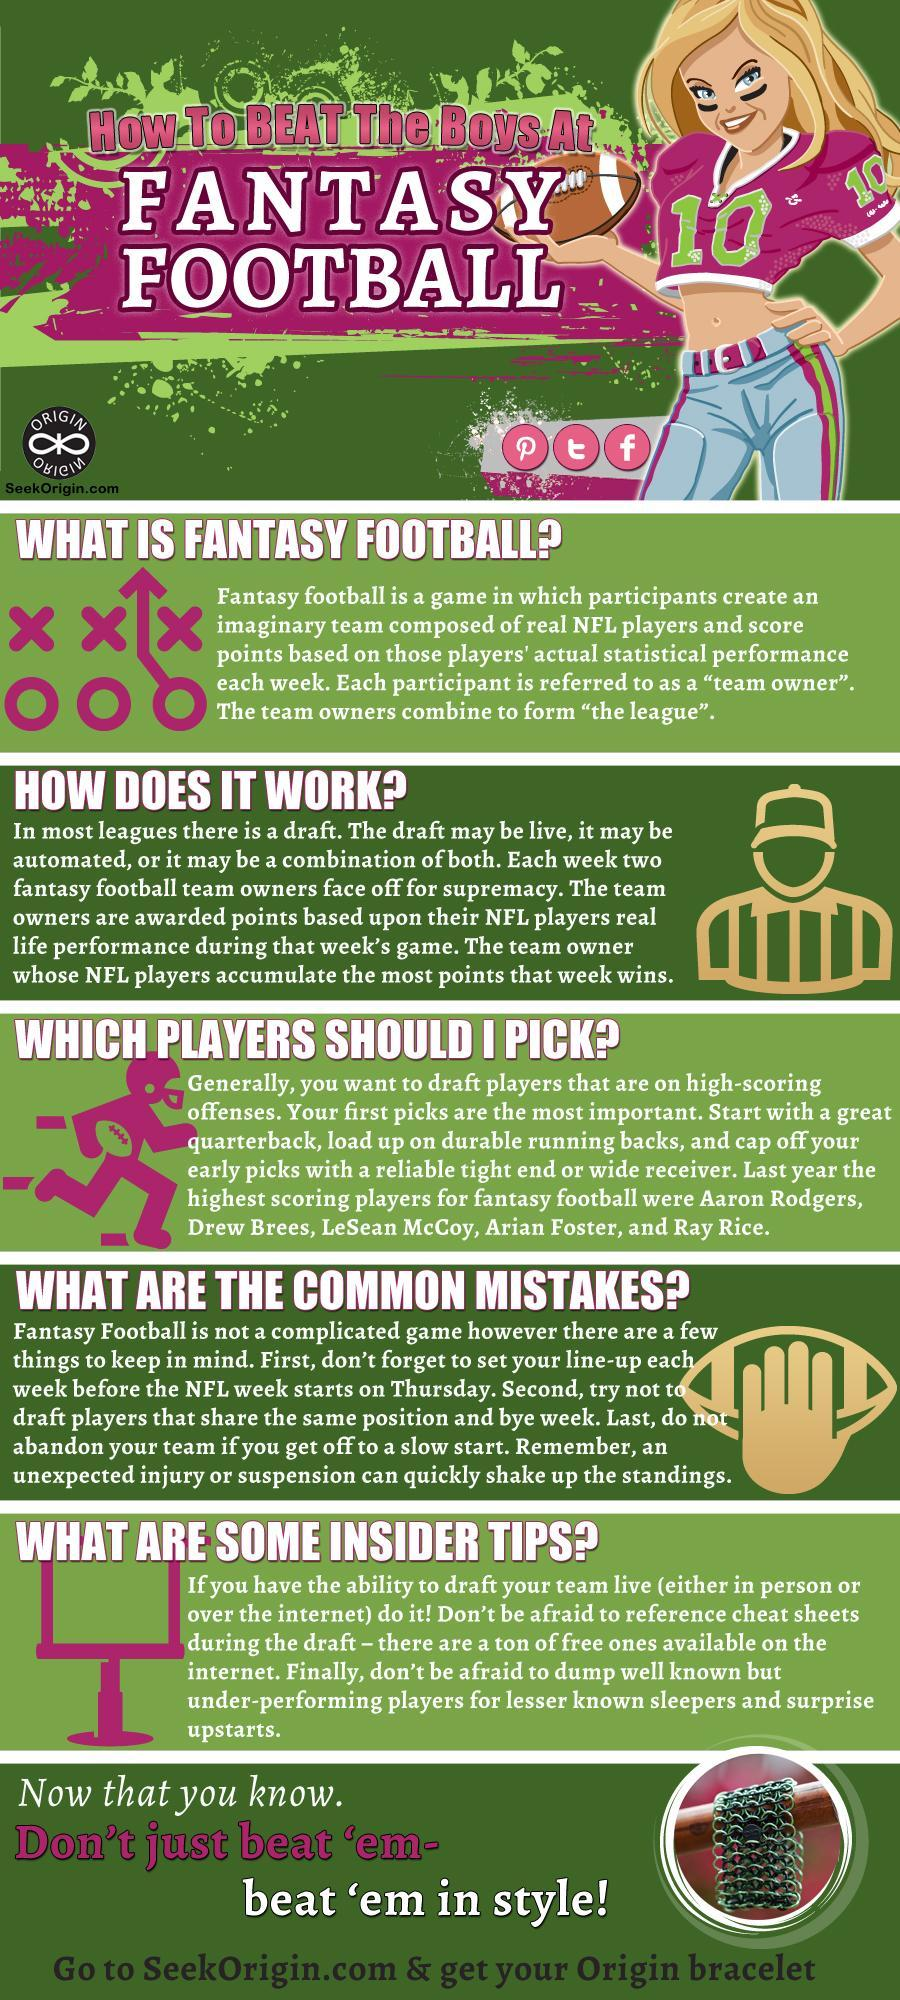What is the name for the group of different participants who own teams of NFL players?
Answer the question with a short phrase. the league The name of which NFL player is written first? Aaron Rodgers Whose name is listed second among the names of high scoring players? Drew Brees 